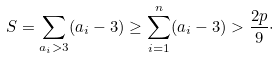<formula> <loc_0><loc_0><loc_500><loc_500>S = \sum _ { a _ { i } > 3 } ( a _ { i } - 3 ) \geq \sum _ { i = 1 } ^ { n } ( a _ { i } - 3 ) > \frac { 2 p } { 9 } \cdot</formula> 